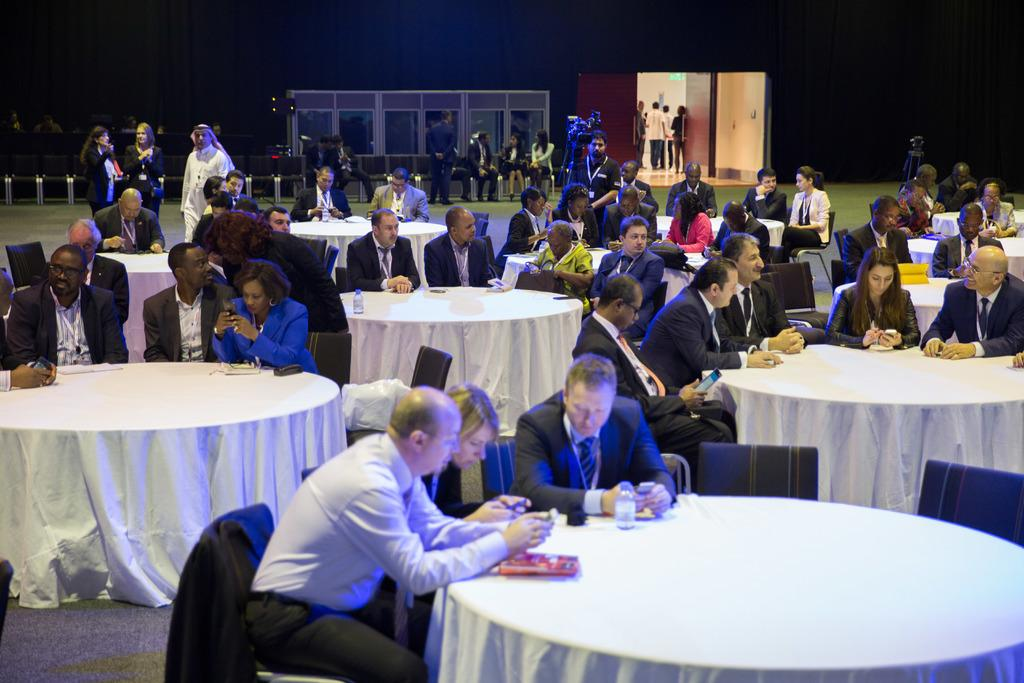What is the arrangement of people in the image? There are people sitting in groups at tables, and there are people sitting separately behind the groups. How are the people at the tables arranged? The people at the tables are sitting in groups. What is the position of the people sitting separately? The people sitting separately are behind the groups at the tables. What type of quill is being used by the people sitting separately? There is no quill present in the image; the people are sitting at tables and not using any writing instruments. 